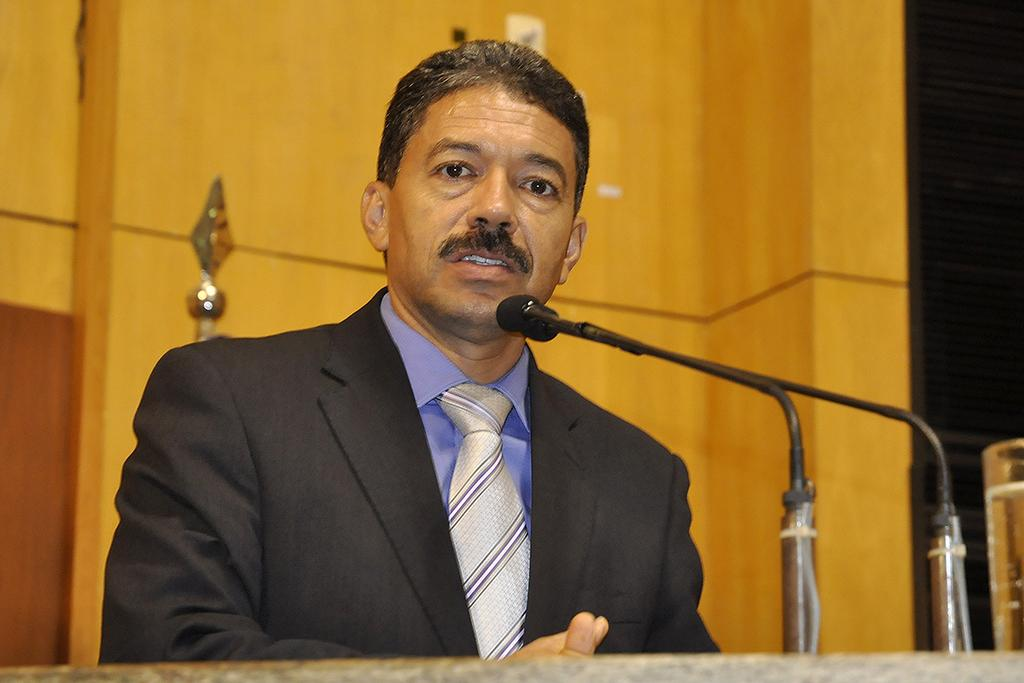Who is present in the image? There is a man in the image. What is the man wearing? The man is wearing a suit. What object is at the front of the image? There is a microphone at the front of the image. What can be seen at the right side of the image? There is a glass of water at the right side of the image. What type of background is visible in the image? There is a wooden background in the image. What type of stone is the man holding in the image? There is no stone present in the image; the man is not holding anything. What type of stew is being prepared in the image? There is no stew or cooking activity present in the image. 